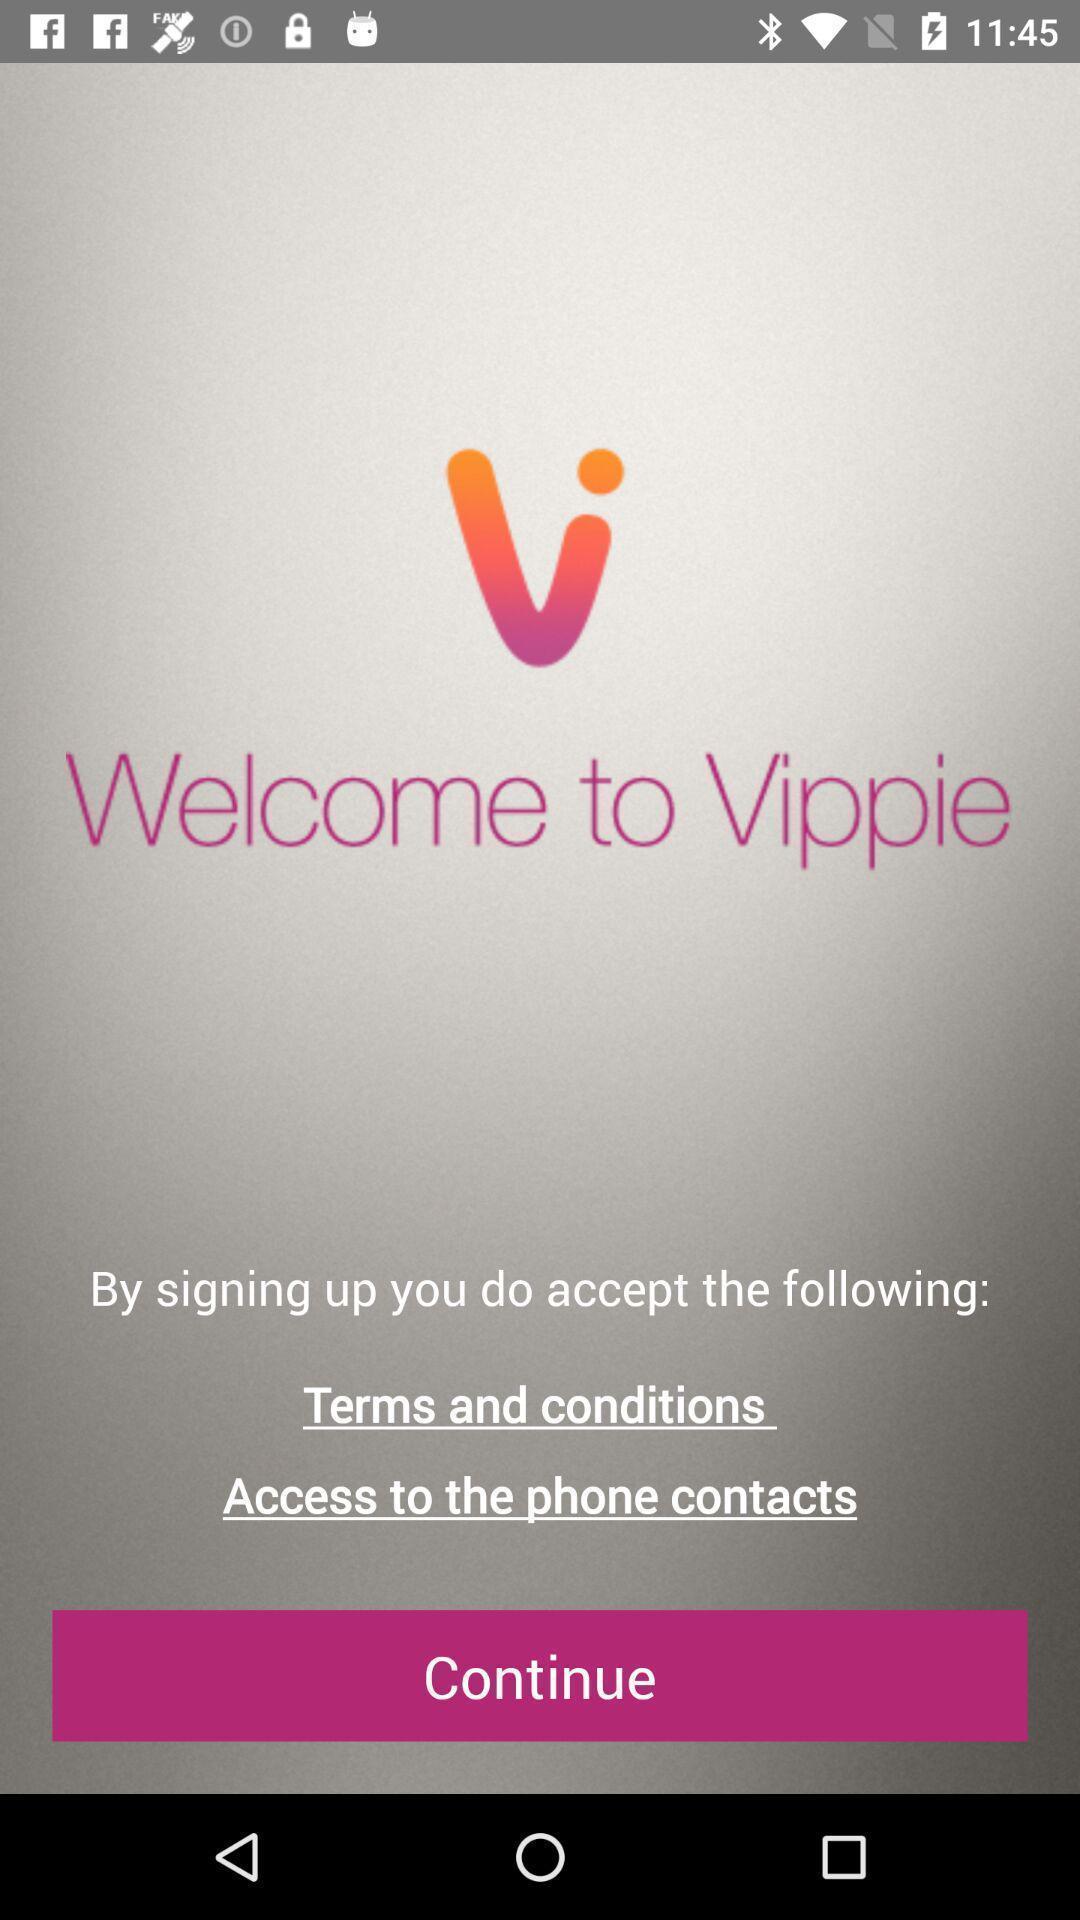What details can you identify in this image? Welcome page. 